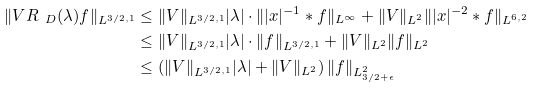Convert formula to latex. <formula><loc_0><loc_0><loc_500><loc_500>\| V R _ { \ D } ( \lambda ) f \| _ { L ^ { 3 / 2 , 1 } } & \leq \| V \| _ { L ^ { 3 / 2 , 1 } } | \lambda | \cdot \| | x | ^ { - 1 } * f \| _ { L ^ { \infty } } + \| V \| _ { L ^ { 2 } } \| | x | ^ { - 2 } * f \| _ { L ^ { 6 , 2 } } \\ & \leq \| V \| _ { L ^ { 3 / 2 , 1 } } | \lambda | \cdot \| f \| _ { L ^ { 3 / 2 , 1 } } + \| V \| _ { L ^ { 2 } } \| f \| _ { L ^ { 2 } } \\ & \leq \left ( \| V \| _ { L ^ { 3 / 2 , 1 } } | \lambda | + \| V \| _ { L ^ { 2 } } \right ) \| f \| _ { L ^ { 2 } _ { 3 / 2 + \epsilon } }</formula> 